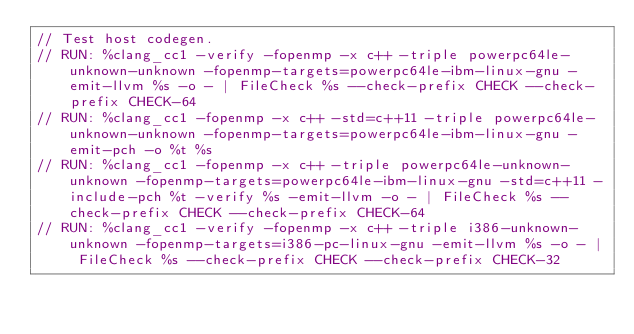<code> <loc_0><loc_0><loc_500><loc_500><_C++_>// Test host codegen.
// RUN: %clang_cc1 -verify -fopenmp -x c++ -triple powerpc64le-unknown-unknown -fopenmp-targets=powerpc64le-ibm-linux-gnu -emit-llvm %s -o - | FileCheck %s --check-prefix CHECK --check-prefix CHECK-64
// RUN: %clang_cc1 -fopenmp -x c++ -std=c++11 -triple powerpc64le-unknown-unknown -fopenmp-targets=powerpc64le-ibm-linux-gnu -emit-pch -o %t %s
// RUN: %clang_cc1 -fopenmp -x c++ -triple powerpc64le-unknown-unknown -fopenmp-targets=powerpc64le-ibm-linux-gnu -std=c++11 -include-pch %t -verify %s -emit-llvm -o - | FileCheck %s --check-prefix CHECK --check-prefix CHECK-64
// RUN: %clang_cc1 -verify -fopenmp -x c++ -triple i386-unknown-unknown -fopenmp-targets=i386-pc-linux-gnu -emit-llvm %s -o - | FileCheck %s --check-prefix CHECK --check-prefix CHECK-32</code> 